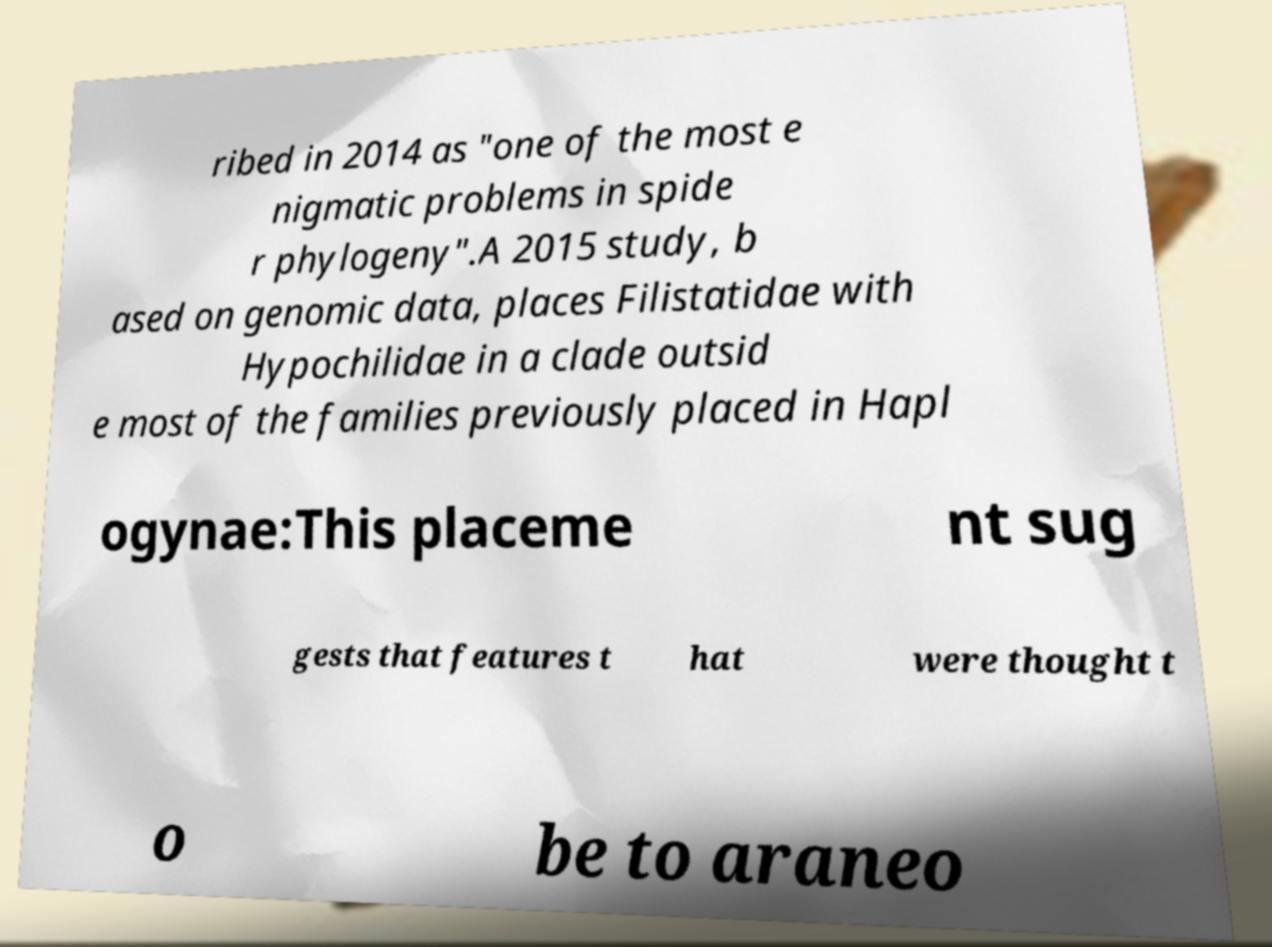Could you extract and type out the text from this image? ribed in 2014 as "one of the most e nigmatic problems in spide r phylogeny".A 2015 study, b ased on genomic data, places Filistatidae with Hypochilidae in a clade outsid e most of the families previously placed in Hapl ogynae:This placeme nt sug gests that features t hat were thought t o be to araneo 